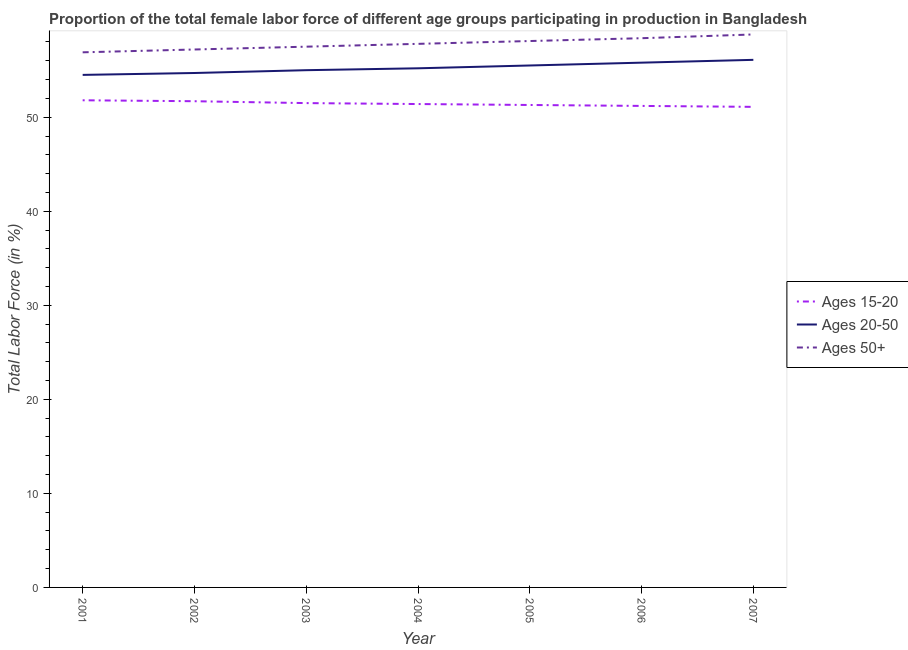How many different coloured lines are there?
Ensure brevity in your answer.  3. Does the line corresponding to percentage of female labor force within the age group 15-20 intersect with the line corresponding to percentage of female labor force above age 50?
Provide a succinct answer. No. Is the number of lines equal to the number of legend labels?
Give a very brief answer. Yes. What is the percentage of female labor force within the age group 15-20 in 2005?
Make the answer very short. 51.3. Across all years, what is the maximum percentage of female labor force within the age group 15-20?
Offer a terse response. 51.8. Across all years, what is the minimum percentage of female labor force above age 50?
Give a very brief answer. 56.9. What is the total percentage of female labor force above age 50 in the graph?
Your response must be concise. 404.7. What is the difference between the percentage of female labor force within the age group 20-50 in 2001 and that in 2005?
Provide a succinct answer. -1. What is the average percentage of female labor force within the age group 20-50 per year?
Ensure brevity in your answer.  55.26. In the year 2005, what is the difference between the percentage of female labor force within the age group 15-20 and percentage of female labor force within the age group 20-50?
Offer a terse response. -4.2. In how many years, is the percentage of female labor force within the age group 15-20 greater than 32 %?
Make the answer very short. 7. What is the ratio of the percentage of female labor force above age 50 in 2005 to that in 2007?
Your answer should be compact. 0.99. Is the difference between the percentage of female labor force within the age group 15-20 in 2001 and 2006 greater than the difference between the percentage of female labor force within the age group 20-50 in 2001 and 2006?
Keep it short and to the point. Yes. What is the difference between the highest and the second highest percentage of female labor force above age 50?
Your answer should be compact. 0.4. What is the difference between the highest and the lowest percentage of female labor force above age 50?
Offer a terse response. 1.9. Is it the case that in every year, the sum of the percentage of female labor force within the age group 15-20 and percentage of female labor force within the age group 20-50 is greater than the percentage of female labor force above age 50?
Make the answer very short. Yes. Is the percentage of female labor force within the age group 15-20 strictly greater than the percentage of female labor force above age 50 over the years?
Offer a terse response. No. Does the graph contain grids?
Offer a very short reply. No. Where does the legend appear in the graph?
Give a very brief answer. Center right. How are the legend labels stacked?
Give a very brief answer. Vertical. What is the title of the graph?
Make the answer very short. Proportion of the total female labor force of different age groups participating in production in Bangladesh. What is the label or title of the Y-axis?
Offer a very short reply. Total Labor Force (in %). What is the Total Labor Force (in %) of Ages 15-20 in 2001?
Offer a very short reply. 51.8. What is the Total Labor Force (in %) in Ages 20-50 in 2001?
Provide a succinct answer. 54.5. What is the Total Labor Force (in %) of Ages 50+ in 2001?
Provide a succinct answer. 56.9. What is the Total Labor Force (in %) in Ages 15-20 in 2002?
Your answer should be compact. 51.7. What is the Total Labor Force (in %) of Ages 20-50 in 2002?
Provide a short and direct response. 54.7. What is the Total Labor Force (in %) in Ages 50+ in 2002?
Ensure brevity in your answer.  57.2. What is the Total Labor Force (in %) of Ages 15-20 in 2003?
Give a very brief answer. 51.5. What is the Total Labor Force (in %) of Ages 20-50 in 2003?
Ensure brevity in your answer.  55. What is the Total Labor Force (in %) of Ages 50+ in 2003?
Make the answer very short. 57.5. What is the Total Labor Force (in %) of Ages 15-20 in 2004?
Your response must be concise. 51.4. What is the Total Labor Force (in %) in Ages 20-50 in 2004?
Keep it short and to the point. 55.2. What is the Total Labor Force (in %) in Ages 50+ in 2004?
Provide a short and direct response. 57.8. What is the Total Labor Force (in %) in Ages 15-20 in 2005?
Your answer should be very brief. 51.3. What is the Total Labor Force (in %) of Ages 20-50 in 2005?
Provide a short and direct response. 55.5. What is the Total Labor Force (in %) in Ages 50+ in 2005?
Make the answer very short. 58.1. What is the Total Labor Force (in %) of Ages 15-20 in 2006?
Offer a terse response. 51.2. What is the Total Labor Force (in %) of Ages 20-50 in 2006?
Your response must be concise. 55.8. What is the Total Labor Force (in %) of Ages 50+ in 2006?
Offer a very short reply. 58.4. What is the Total Labor Force (in %) of Ages 15-20 in 2007?
Make the answer very short. 51.1. What is the Total Labor Force (in %) of Ages 20-50 in 2007?
Offer a very short reply. 56.1. What is the Total Labor Force (in %) of Ages 50+ in 2007?
Give a very brief answer. 58.8. Across all years, what is the maximum Total Labor Force (in %) of Ages 15-20?
Ensure brevity in your answer.  51.8. Across all years, what is the maximum Total Labor Force (in %) in Ages 20-50?
Offer a terse response. 56.1. Across all years, what is the maximum Total Labor Force (in %) of Ages 50+?
Ensure brevity in your answer.  58.8. Across all years, what is the minimum Total Labor Force (in %) in Ages 15-20?
Keep it short and to the point. 51.1. Across all years, what is the minimum Total Labor Force (in %) in Ages 20-50?
Keep it short and to the point. 54.5. Across all years, what is the minimum Total Labor Force (in %) in Ages 50+?
Offer a terse response. 56.9. What is the total Total Labor Force (in %) in Ages 15-20 in the graph?
Your answer should be very brief. 360. What is the total Total Labor Force (in %) of Ages 20-50 in the graph?
Ensure brevity in your answer.  386.8. What is the total Total Labor Force (in %) in Ages 50+ in the graph?
Your answer should be very brief. 404.7. What is the difference between the Total Labor Force (in %) in Ages 20-50 in 2001 and that in 2002?
Your answer should be very brief. -0.2. What is the difference between the Total Labor Force (in %) in Ages 15-20 in 2001 and that in 2003?
Offer a terse response. 0.3. What is the difference between the Total Labor Force (in %) of Ages 20-50 in 2001 and that in 2003?
Your answer should be compact. -0.5. What is the difference between the Total Labor Force (in %) in Ages 15-20 in 2001 and that in 2004?
Give a very brief answer. 0.4. What is the difference between the Total Labor Force (in %) in Ages 50+ in 2001 and that in 2004?
Provide a succinct answer. -0.9. What is the difference between the Total Labor Force (in %) in Ages 20-50 in 2001 and that in 2005?
Provide a succinct answer. -1. What is the difference between the Total Labor Force (in %) of Ages 15-20 in 2001 and that in 2006?
Offer a terse response. 0.6. What is the difference between the Total Labor Force (in %) in Ages 20-50 in 2001 and that in 2006?
Provide a succinct answer. -1.3. What is the difference between the Total Labor Force (in %) of Ages 15-20 in 2001 and that in 2007?
Your answer should be very brief. 0.7. What is the difference between the Total Labor Force (in %) of Ages 50+ in 2001 and that in 2007?
Provide a short and direct response. -1.9. What is the difference between the Total Labor Force (in %) in Ages 15-20 in 2002 and that in 2003?
Offer a terse response. 0.2. What is the difference between the Total Labor Force (in %) of Ages 50+ in 2002 and that in 2003?
Offer a terse response. -0.3. What is the difference between the Total Labor Force (in %) in Ages 15-20 in 2002 and that in 2004?
Offer a terse response. 0.3. What is the difference between the Total Labor Force (in %) of Ages 20-50 in 2002 and that in 2005?
Offer a very short reply. -0.8. What is the difference between the Total Labor Force (in %) in Ages 15-20 in 2002 and that in 2007?
Offer a terse response. 0.6. What is the difference between the Total Labor Force (in %) in Ages 15-20 in 2003 and that in 2004?
Give a very brief answer. 0.1. What is the difference between the Total Labor Force (in %) in Ages 50+ in 2003 and that in 2004?
Ensure brevity in your answer.  -0.3. What is the difference between the Total Labor Force (in %) in Ages 20-50 in 2003 and that in 2005?
Your response must be concise. -0.5. What is the difference between the Total Labor Force (in %) in Ages 50+ in 2003 and that in 2005?
Ensure brevity in your answer.  -0.6. What is the difference between the Total Labor Force (in %) in Ages 50+ in 2003 and that in 2006?
Offer a very short reply. -0.9. What is the difference between the Total Labor Force (in %) of Ages 20-50 in 2003 and that in 2007?
Your answer should be compact. -1.1. What is the difference between the Total Labor Force (in %) in Ages 15-20 in 2004 and that in 2006?
Make the answer very short. 0.2. What is the difference between the Total Labor Force (in %) in Ages 15-20 in 2004 and that in 2007?
Your answer should be compact. 0.3. What is the difference between the Total Labor Force (in %) in Ages 20-50 in 2004 and that in 2007?
Keep it short and to the point. -0.9. What is the difference between the Total Labor Force (in %) of Ages 50+ in 2004 and that in 2007?
Keep it short and to the point. -1. What is the difference between the Total Labor Force (in %) of Ages 15-20 in 2005 and that in 2006?
Your answer should be very brief. 0.1. What is the difference between the Total Labor Force (in %) of Ages 20-50 in 2005 and that in 2006?
Your response must be concise. -0.3. What is the difference between the Total Labor Force (in %) in Ages 15-20 in 2005 and that in 2007?
Make the answer very short. 0.2. What is the difference between the Total Labor Force (in %) in Ages 50+ in 2005 and that in 2007?
Provide a short and direct response. -0.7. What is the difference between the Total Labor Force (in %) in Ages 50+ in 2006 and that in 2007?
Keep it short and to the point. -0.4. What is the difference between the Total Labor Force (in %) in Ages 15-20 in 2001 and the Total Labor Force (in %) in Ages 20-50 in 2002?
Give a very brief answer. -2.9. What is the difference between the Total Labor Force (in %) in Ages 20-50 in 2001 and the Total Labor Force (in %) in Ages 50+ in 2002?
Your answer should be very brief. -2.7. What is the difference between the Total Labor Force (in %) in Ages 15-20 in 2001 and the Total Labor Force (in %) in Ages 50+ in 2003?
Give a very brief answer. -5.7. What is the difference between the Total Labor Force (in %) in Ages 20-50 in 2001 and the Total Labor Force (in %) in Ages 50+ in 2003?
Your response must be concise. -3. What is the difference between the Total Labor Force (in %) in Ages 15-20 in 2001 and the Total Labor Force (in %) in Ages 20-50 in 2004?
Offer a terse response. -3.4. What is the difference between the Total Labor Force (in %) in Ages 15-20 in 2001 and the Total Labor Force (in %) in Ages 50+ in 2004?
Your answer should be compact. -6. What is the difference between the Total Labor Force (in %) of Ages 20-50 in 2001 and the Total Labor Force (in %) of Ages 50+ in 2004?
Your answer should be very brief. -3.3. What is the difference between the Total Labor Force (in %) of Ages 15-20 in 2001 and the Total Labor Force (in %) of Ages 20-50 in 2005?
Make the answer very short. -3.7. What is the difference between the Total Labor Force (in %) of Ages 15-20 in 2001 and the Total Labor Force (in %) of Ages 20-50 in 2006?
Your answer should be very brief. -4. What is the difference between the Total Labor Force (in %) in Ages 15-20 in 2001 and the Total Labor Force (in %) in Ages 50+ in 2006?
Make the answer very short. -6.6. What is the difference between the Total Labor Force (in %) of Ages 20-50 in 2001 and the Total Labor Force (in %) of Ages 50+ in 2006?
Your answer should be very brief. -3.9. What is the difference between the Total Labor Force (in %) in Ages 15-20 in 2001 and the Total Labor Force (in %) in Ages 20-50 in 2007?
Your response must be concise. -4.3. What is the difference between the Total Labor Force (in %) in Ages 15-20 in 2002 and the Total Labor Force (in %) in Ages 20-50 in 2003?
Your answer should be very brief. -3.3. What is the difference between the Total Labor Force (in %) in Ages 15-20 in 2002 and the Total Labor Force (in %) in Ages 20-50 in 2004?
Give a very brief answer. -3.5. What is the difference between the Total Labor Force (in %) in Ages 15-20 in 2002 and the Total Labor Force (in %) in Ages 50+ in 2004?
Give a very brief answer. -6.1. What is the difference between the Total Labor Force (in %) in Ages 20-50 in 2002 and the Total Labor Force (in %) in Ages 50+ in 2004?
Keep it short and to the point. -3.1. What is the difference between the Total Labor Force (in %) in Ages 15-20 in 2002 and the Total Labor Force (in %) in Ages 20-50 in 2005?
Keep it short and to the point. -3.8. What is the difference between the Total Labor Force (in %) of Ages 15-20 in 2002 and the Total Labor Force (in %) of Ages 50+ in 2005?
Your answer should be very brief. -6.4. What is the difference between the Total Labor Force (in %) of Ages 20-50 in 2002 and the Total Labor Force (in %) of Ages 50+ in 2005?
Offer a very short reply. -3.4. What is the difference between the Total Labor Force (in %) in Ages 15-20 in 2002 and the Total Labor Force (in %) in Ages 20-50 in 2006?
Provide a short and direct response. -4.1. What is the difference between the Total Labor Force (in %) in Ages 15-20 in 2003 and the Total Labor Force (in %) in Ages 20-50 in 2004?
Offer a terse response. -3.7. What is the difference between the Total Labor Force (in %) of Ages 15-20 in 2003 and the Total Labor Force (in %) of Ages 50+ in 2006?
Ensure brevity in your answer.  -6.9. What is the difference between the Total Labor Force (in %) of Ages 15-20 in 2003 and the Total Labor Force (in %) of Ages 20-50 in 2007?
Make the answer very short. -4.6. What is the difference between the Total Labor Force (in %) of Ages 15-20 in 2004 and the Total Labor Force (in %) of Ages 20-50 in 2005?
Your answer should be very brief. -4.1. What is the difference between the Total Labor Force (in %) in Ages 15-20 in 2004 and the Total Labor Force (in %) in Ages 20-50 in 2006?
Make the answer very short. -4.4. What is the difference between the Total Labor Force (in %) of Ages 20-50 in 2004 and the Total Labor Force (in %) of Ages 50+ in 2006?
Give a very brief answer. -3.2. What is the difference between the Total Labor Force (in %) of Ages 15-20 in 2004 and the Total Labor Force (in %) of Ages 50+ in 2007?
Keep it short and to the point. -7.4. What is the difference between the Total Labor Force (in %) in Ages 20-50 in 2004 and the Total Labor Force (in %) in Ages 50+ in 2007?
Give a very brief answer. -3.6. What is the difference between the Total Labor Force (in %) of Ages 15-20 in 2005 and the Total Labor Force (in %) of Ages 20-50 in 2006?
Provide a short and direct response. -4.5. What is the difference between the Total Labor Force (in %) in Ages 20-50 in 2005 and the Total Labor Force (in %) in Ages 50+ in 2006?
Your answer should be compact. -2.9. What is the difference between the Total Labor Force (in %) of Ages 15-20 in 2005 and the Total Labor Force (in %) of Ages 50+ in 2007?
Provide a succinct answer. -7.5. What is the difference between the Total Labor Force (in %) in Ages 20-50 in 2005 and the Total Labor Force (in %) in Ages 50+ in 2007?
Provide a succinct answer. -3.3. What is the difference between the Total Labor Force (in %) of Ages 15-20 in 2006 and the Total Labor Force (in %) of Ages 20-50 in 2007?
Offer a very short reply. -4.9. What is the difference between the Total Labor Force (in %) in Ages 20-50 in 2006 and the Total Labor Force (in %) in Ages 50+ in 2007?
Keep it short and to the point. -3. What is the average Total Labor Force (in %) in Ages 15-20 per year?
Ensure brevity in your answer.  51.43. What is the average Total Labor Force (in %) of Ages 20-50 per year?
Keep it short and to the point. 55.26. What is the average Total Labor Force (in %) in Ages 50+ per year?
Your answer should be compact. 57.81. In the year 2001, what is the difference between the Total Labor Force (in %) of Ages 20-50 and Total Labor Force (in %) of Ages 50+?
Provide a succinct answer. -2.4. In the year 2002, what is the difference between the Total Labor Force (in %) in Ages 15-20 and Total Labor Force (in %) in Ages 20-50?
Provide a succinct answer. -3. In the year 2002, what is the difference between the Total Labor Force (in %) of Ages 15-20 and Total Labor Force (in %) of Ages 50+?
Make the answer very short. -5.5. In the year 2002, what is the difference between the Total Labor Force (in %) of Ages 20-50 and Total Labor Force (in %) of Ages 50+?
Keep it short and to the point. -2.5. In the year 2004, what is the difference between the Total Labor Force (in %) in Ages 15-20 and Total Labor Force (in %) in Ages 50+?
Your answer should be very brief. -6.4. In the year 2004, what is the difference between the Total Labor Force (in %) of Ages 20-50 and Total Labor Force (in %) of Ages 50+?
Offer a very short reply. -2.6. In the year 2005, what is the difference between the Total Labor Force (in %) of Ages 15-20 and Total Labor Force (in %) of Ages 20-50?
Offer a terse response. -4.2. In the year 2005, what is the difference between the Total Labor Force (in %) of Ages 20-50 and Total Labor Force (in %) of Ages 50+?
Your answer should be very brief. -2.6. In the year 2006, what is the difference between the Total Labor Force (in %) in Ages 15-20 and Total Labor Force (in %) in Ages 20-50?
Your answer should be compact. -4.6. In the year 2007, what is the difference between the Total Labor Force (in %) of Ages 15-20 and Total Labor Force (in %) of Ages 20-50?
Give a very brief answer. -5. In the year 2007, what is the difference between the Total Labor Force (in %) in Ages 15-20 and Total Labor Force (in %) in Ages 50+?
Offer a terse response. -7.7. What is the ratio of the Total Labor Force (in %) of Ages 50+ in 2001 to that in 2002?
Your answer should be compact. 0.99. What is the ratio of the Total Labor Force (in %) in Ages 20-50 in 2001 to that in 2003?
Provide a short and direct response. 0.99. What is the ratio of the Total Labor Force (in %) of Ages 20-50 in 2001 to that in 2004?
Your answer should be very brief. 0.99. What is the ratio of the Total Labor Force (in %) of Ages 50+ in 2001 to that in 2004?
Provide a short and direct response. 0.98. What is the ratio of the Total Labor Force (in %) of Ages 15-20 in 2001 to that in 2005?
Provide a succinct answer. 1.01. What is the ratio of the Total Labor Force (in %) of Ages 20-50 in 2001 to that in 2005?
Provide a short and direct response. 0.98. What is the ratio of the Total Labor Force (in %) of Ages 50+ in 2001 to that in 2005?
Offer a terse response. 0.98. What is the ratio of the Total Labor Force (in %) of Ages 15-20 in 2001 to that in 2006?
Your response must be concise. 1.01. What is the ratio of the Total Labor Force (in %) of Ages 20-50 in 2001 to that in 2006?
Ensure brevity in your answer.  0.98. What is the ratio of the Total Labor Force (in %) in Ages 50+ in 2001 to that in 2006?
Provide a short and direct response. 0.97. What is the ratio of the Total Labor Force (in %) of Ages 15-20 in 2001 to that in 2007?
Ensure brevity in your answer.  1.01. What is the ratio of the Total Labor Force (in %) of Ages 20-50 in 2001 to that in 2007?
Keep it short and to the point. 0.97. What is the ratio of the Total Labor Force (in %) of Ages 15-20 in 2002 to that in 2003?
Your answer should be compact. 1. What is the ratio of the Total Labor Force (in %) in Ages 20-50 in 2002 to that in 2003?
Your answer should be very brief. 0.99. What is the ratio of the Total Labor Force (in %) in Ages 50+ in 2002 to that in 2003?
Give a very brief answer. 0.99. What is the ratio of the Total Labor Force (in %) of Ages 20-50 in 2002 to that in 2004?
Your response must be concise. 0.99. What is the ratio of the Total Labor Force (in %) of Ages 50+ in 2002 to that in 2004?
Ensure brevity in your answer.  0.99. What is the ratio of the Total Labor Force (in %) of Ages 20-50 in 2002 to that in 2005?
Offer a very short reply. 0.99. What is the ratio of the Total Labor Force (in %) of Ages 50+ in 2002 to that in 2005?
Your answer should be compact. 0.98. What is the ratio of the Total Labor Force (in %) of Ages 15-20 in 2002 to that in 2006?
Offer a terse response. 1.01. What is the ratio of the Total Labor Force (in %) in Ages 20-50 in 2002 to that in 2006?
Make the answer very short. 0.98. What is the ratio of the Total Labor Force (in %) of Ages 50+ in 2002 to that in 2006?
Your answer should be compact. 0.98. What is the ratio of the Total Labor Force (in %) of Ages 15-20 in 2002 to that in 2007?
Your answer should be compact. 1.01. What is the ratio of the Total Labor Force (in %) of Ages 20-50 in 2002 to that in 2007?
Your response must be concise. 0.97. What is the ratio of the Total Labor Force (in %) of Ages 50+ in 2002 to that in 2007?
Your response must be concise. 0.97. What is the ratio of the Total Labor Force (in %) in Ages 20-50 in 2003 to that in 2004?
Keep it short and to the point. 1. What is the ratio of the Total Labor Force (in %) in Ages 15-20 in 2003 to that in 2005?
Offer a very short reply. 1. What is the ratio of the Total Labor Force (in %) in Ages 20-50 in 2003 to that in 2005?
Provide a short and direct response. 0.99. What is the ratio of the Total Labor Force (in %) in Ages 50+ in 2003 to that in 2005?
Your answer should be compact. 0.99. What is the ratio of the Total Labor Force (in %) of Ages 15-20 in 2003 to that in 2006?
Provide a succinct answer. 1.01. What is the ratio of the Total Labor Force (in %) in Ages 20-50 in 2003 to that in 2006?
Give a very brief answer. 0.99. What is the ratio of the Total Labor Force (in %) in Ages 50+ in 2003 to that in 2006?
Offer a terse response. 0.98. What is the ratio of the Total Labor Force (in %) in Ages 15-20 in 2003 to that in 2007?
Ensure brevity in your answer.  1.01. What is the ratio of the Total Labor Force (in %) of Ages 20-50 in 2003 to that in 2007?
Your response must be concise. 0.98. What is the ratio of the Total Labor Force (in %) of Ages 50+ in 2003 to that in 2007?
Your answer should be very brief. 0.98. What is the ratio of the Total Labor Force (in %) in Ages 50+ in 2004 to that in 2005?
Offer a very short reply. 0.99. What is the ratio of the Total Labor Force (in %) of Ages 20-50 in 2004 to that in 2006?
Ensure brevity in your answer.  0.99. What is the ratio of the Total Labor Force (in %) of Ages 15-20 in 2004 to that in 2007?
Provide a short and direct response. 1.01. What is the ratio of the Total Labor Force (in %) in Ages 50+ in 2004 to that in 2007?
Give a very brief answer. 0.98. What is the ratio of the Total Labor Force (in %) in Ages 20-50 in 2005 to that in 2006?
Your response must be concise. 0.99. What is the ratio of the Total Labor Force (in %) of Ages 20-50 in 2005 to that in 2007?
Provide a short and direct response. 0.99. What is the ratio of the Total Labor Force (in %) in Ages 20-50 in 2006 to that in 2007?
Offer a very short reply. 0.99. What is the difference between the highest and the second highest Total Labor Force (in %) in Ages 15-20?
Keep it short and to the point. 0.1. What is the difference between the highest and the second highest Total Labor Force (in %) of Ages 20-50?
Offer a very short reply. 0.3. What is the difference between the highest and the lowest Total Labor Force (in %) of Ages 15-20?
Provide a succinct answer. 0.7. What is the difference between the highest and the lowest Total Labor Force (in %) in Ages 50+?
Keep it short and to the point. 1.9. 